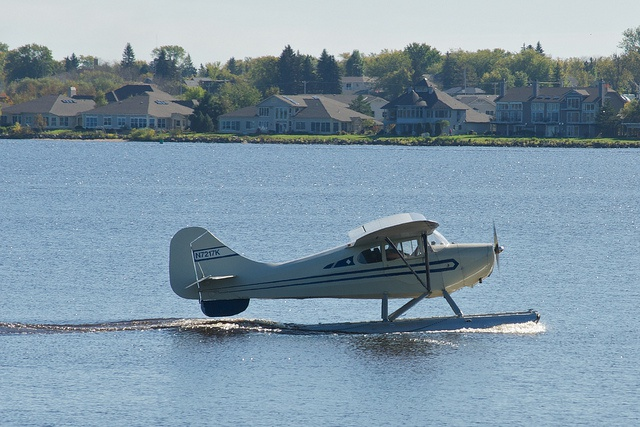Describe the objects in this image and their specific colors. I can see a airplane in lightgray, blue, gray, black, and darkblue tones in this image. 